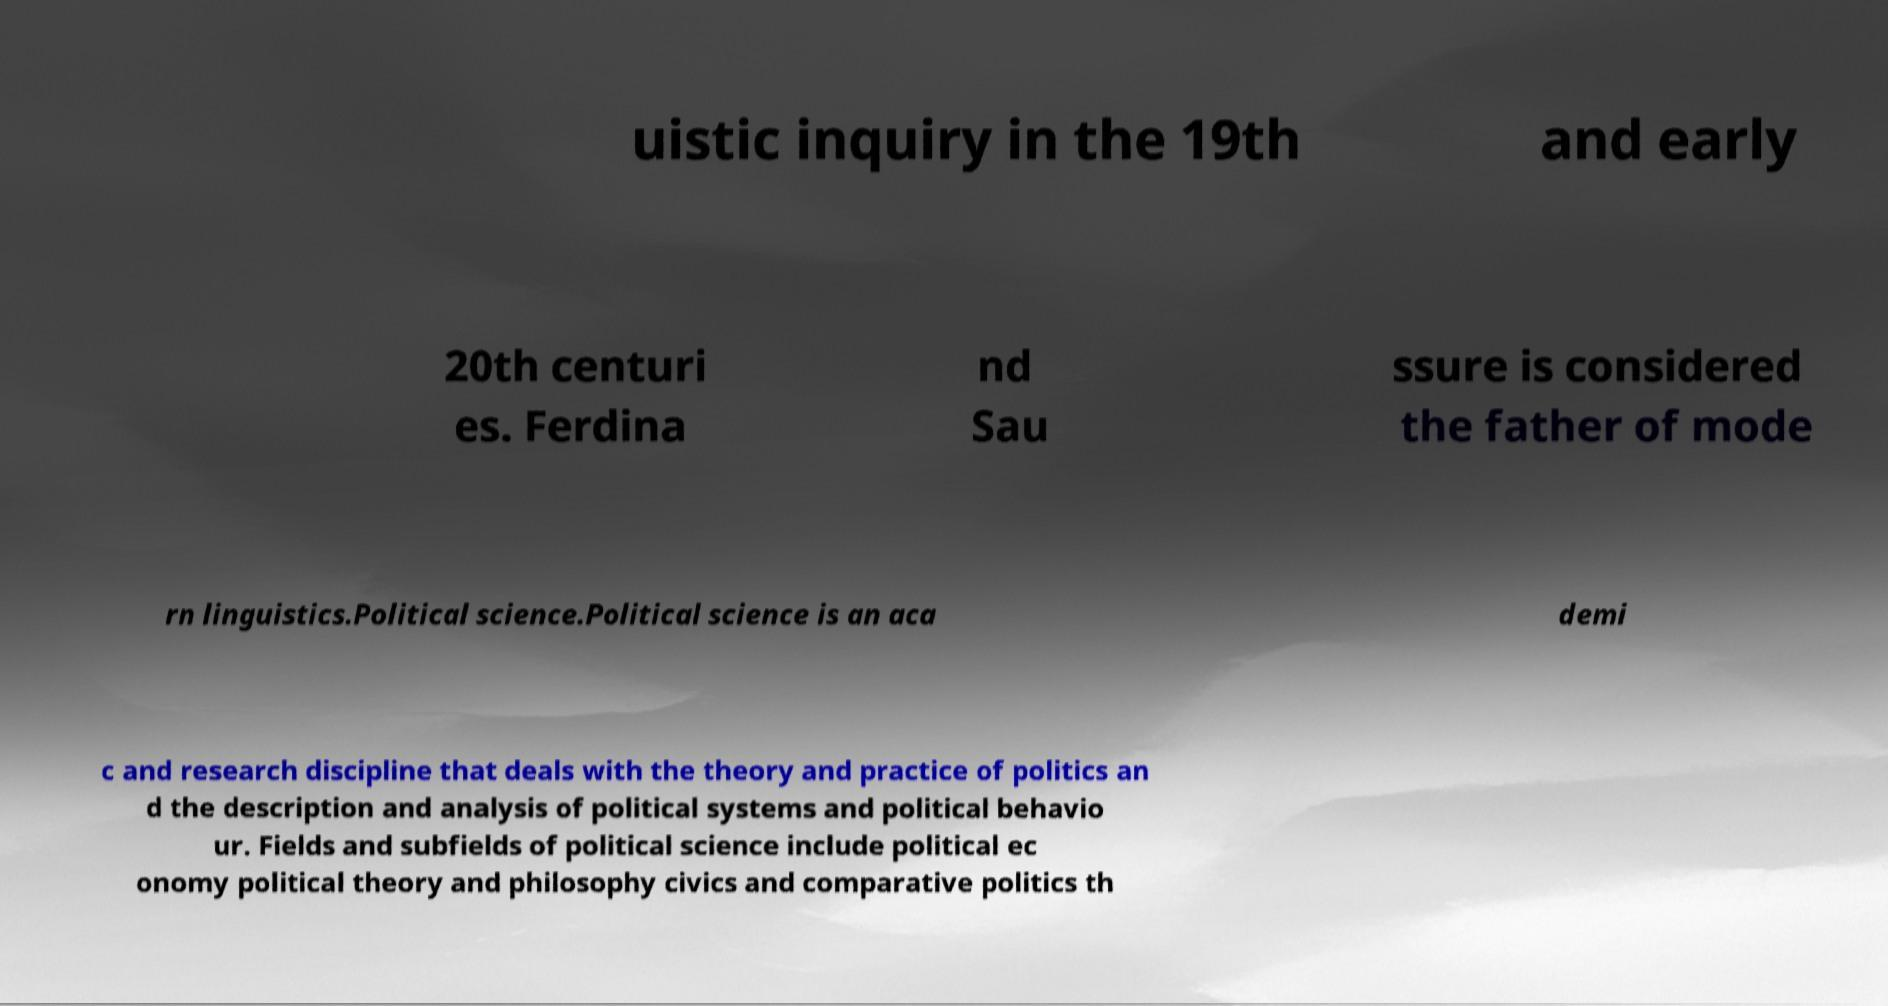Please read and relay the text visible in this image. What does it say? uistic inquiry in the 19th and early 20th centuri es. Ferdina nd Sau ssure is considered the father of mode rn linguistics.Political science.Political science is an aca demi c and research discipline that deals with the theory and practice of politics an d the description and analysis of political systems and political behavio ur. Fields and subfields of political science include political ec onomy political theory and philosophy civics and comparative politics th 